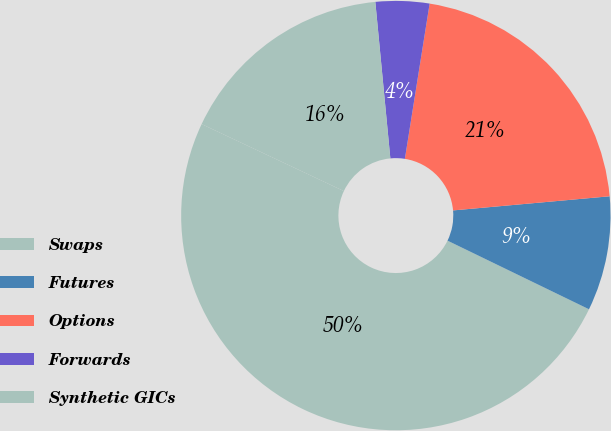Convert chart. <chart><loc_0><loc_0><loc_500><loc_500><pie_chart><fcel>Swaps<fcel>Futures<fcel>Options<fcel>Forwards<fcel>Synthetic GICs<nl><fcel>49.82%<fcel>8.62%<fcel>21.05%<fcel>4.04%<fcel>16.47%<nl></chart> 